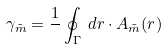<formula> <loc_0><loc_0><loc_500><loc_500>\gamma _ { \tilde { m } } = \frac { 1 } { } \oint _ { \Gamma } \, d { r } \cdot { A } _ { \tilde { m } } ( { r } )</formula> 